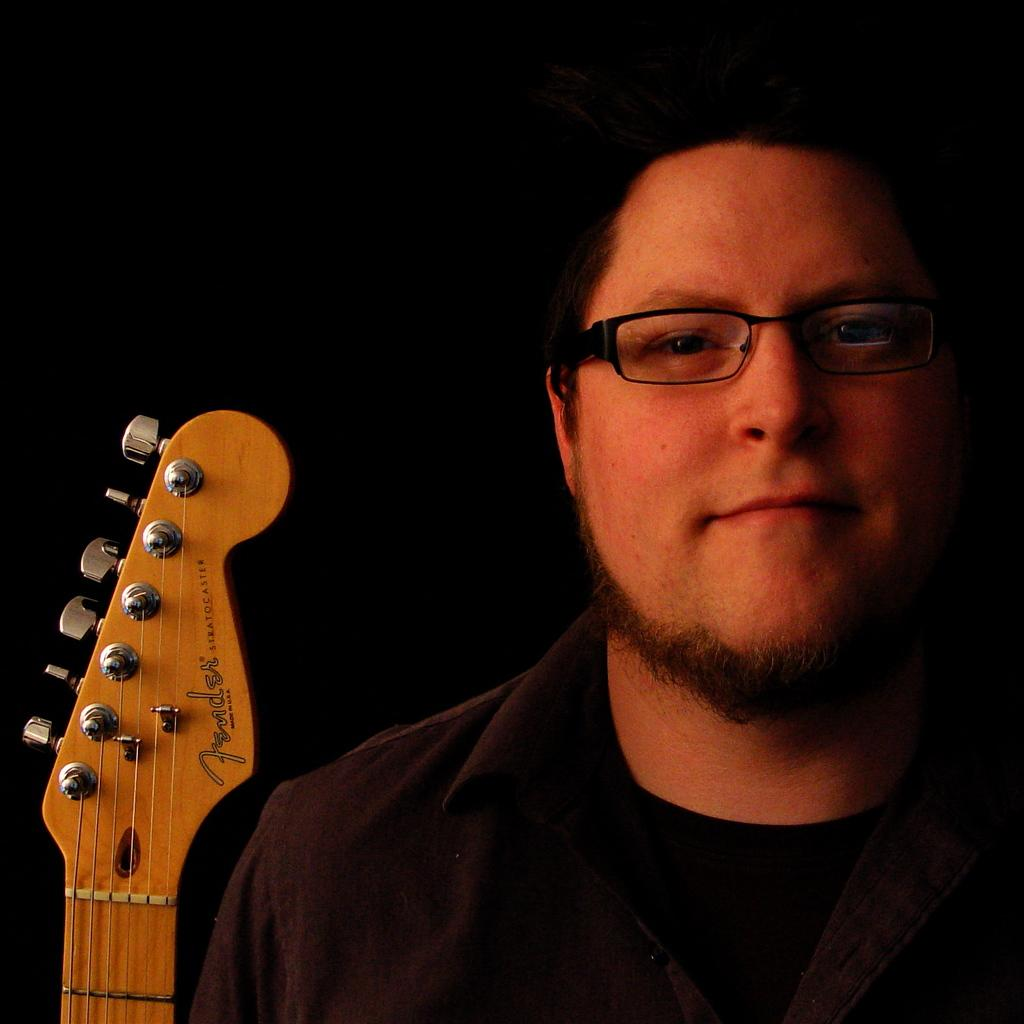What is the person in the image wearing? The person is wearing a black shirt. What accessory can be seen on the person's face? The person is wearing spectacles. What facial hair does the person have? The person has a light beard. What is the person's posture in the image? The person is standing. What musical instrument is placed beside the person? There is a guitar placed beside the person. What is the color of the background in the image? The background of the image is black colored. What type of expert can be seen advising on the preparation of pies in the image? There is no expert or pies present in the image; it features a person standing with a guitar beside them. 